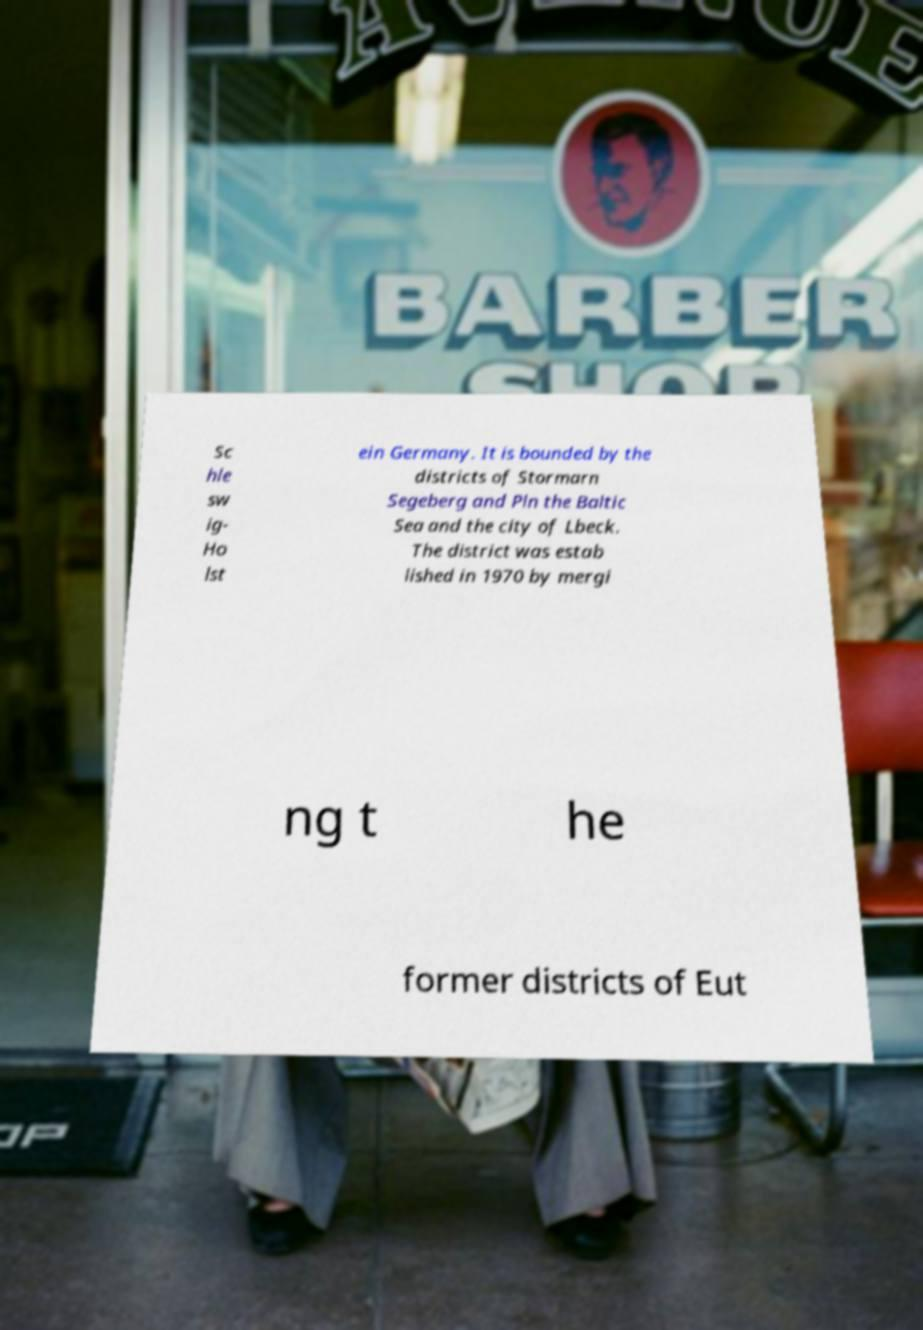What messages or text are displayed in this image? I need them in a readable, typed format. Sc hle sw ig- Ho lst ein Germany. It is bounded by the districts of Stormarn Segeberg and Pln the Baltic Sea and the city of Lbeck. The district was estab lished in 1970 by mergi ng t he former districts of Eut 